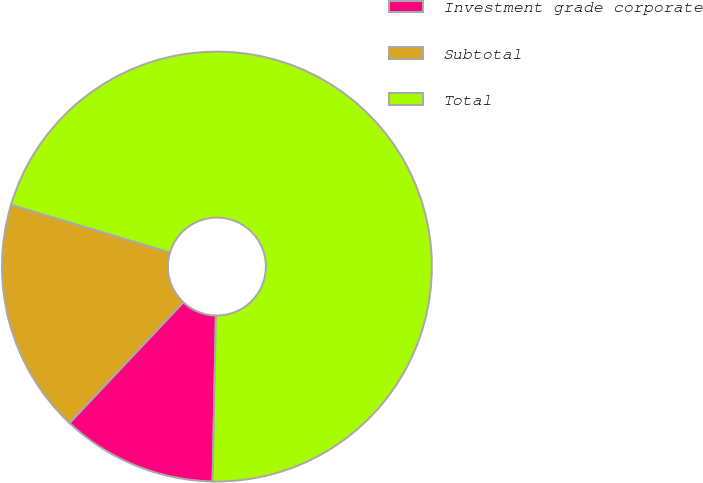Convert chart to OTSL. <chart><loc_0><loc_0><loc_500><loc_500><pie_chart><fcel>Investment grade corporate<fcel>Subtotal<fcel>Total<nl><fcel>11.71%<fcel>17.61%<fcel>70.68%<nl></chart> 